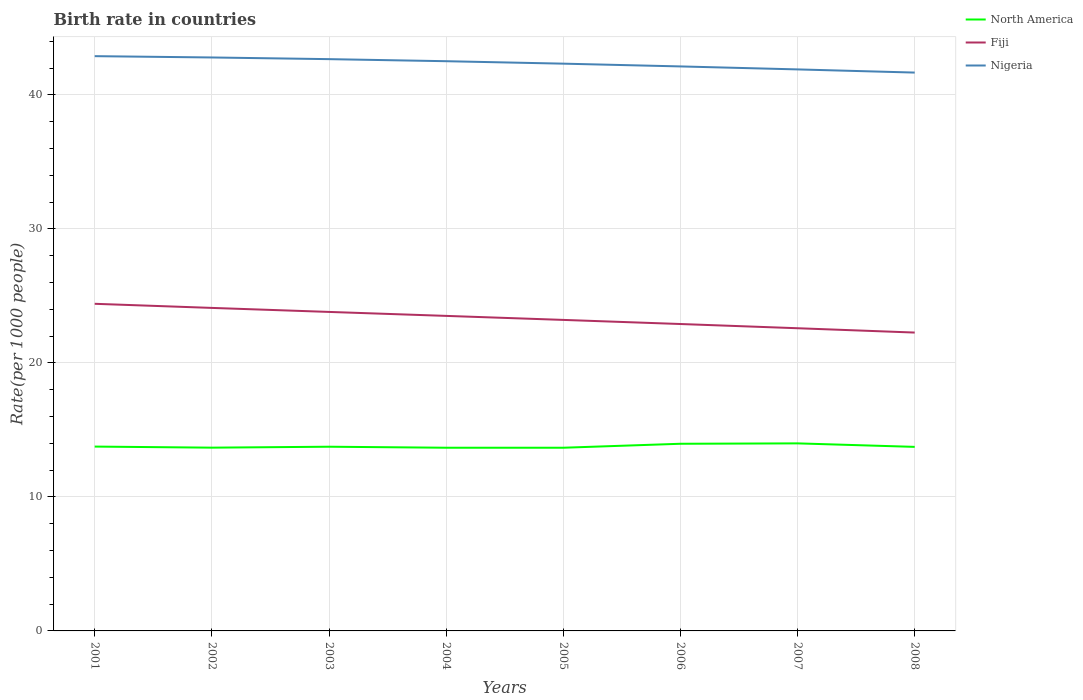Does the line corresponding to North America intersect with the line corresponding to Nigeria?
Give a very brief answer. No. Is the number of lines equal to the number of legend labels?
Offer a very short reply. Yes. Across all years, what is the maximum birth rate in Fiji?
Your response must be concise. 22.26. What is the total birth rate in Nigeria in the graph?
Ensure brevity in your answer.  0.99. What is the difference between the highest and the second highest birth rate in Nigeria?
Keep it short and to the point. 1.23. What is the difference between the highest and the lowest birth rate in North America?
Provide a succinct answer. 2. Is the birth rate in Nigeria strictly greater than the birth rate in North America over the years?
Offer a very short reply. No. How many lines are there?
Your answer should be very brief. 3. What is the difference between two consecutive major ticks on the Y-axis?
Provide a short and direct response. 10. Are the values on the major ticks of Y-axis written in scientific E-notation?
Your response must be concise. No. Where does the legend appear in the graph?
Provide a short and direct response. Top right. What is the title of the graph?
Make the answer very short. Birth rate in countries. Does "Cuba" appear as one of the legend labels in the graph?
Your answer should be compact. No. What is the label or title of the X-axis?
Provide a succinct answer. Years. What is the label or title of the Y-axis?
Offer a terse response. Rate(per 1000 people). What is the Rate(per 1000 people) of North America in 2001?
Ensure brevity in your answer.  13.76. What is the Rate(per 1000 people) in Fiji in 2001?
Give a very brief answer. 24.41. What is the Rate(per 1000 people) of Nigeria in 2001?
Provide a short and direct response. 42.89. What is the Rate(per 1000 people) in North America in 2002?
Offer a very short reply. 13.68. What is the Rate(per 1000 people) of Fiji in 2002?
Provide a short and direct response. 24.1. What is the Rate(per 1000 people) of Nigeria in 2002?
Your response must be concise. 42.79. What is the Rate(per 1000 people) in North America in 2003?
Provide a succinct answer. 13.75. What is the Rate(per 1000 people) in Fiji in 2003?
Provide a short and direct response. 23.8. What is the Rate(per 1000 people) of Nigeria in 2003?
Ensure brevity in your answer.  42.67. What is the Rate(per 1000 people) in North America in 2004?
Your response must be concise. 13.67. What is the Rate(per 1000 people) in Fiji in 2004?
Your answer should be compact. 23.51. What is the Rate(per 1000 people) of Nigeria in 2004?
Provide a short and direct response. 42.51. What is the Rate(per 1000 people) of North America in 2005?
Ensure brevity in your answer.  13.67. What is the Rate(per 1000 people) of Fiji in 2005?
Keep it short and to the point. 23.21. What is the Rate(per 1000 people) of Nigeria in 2005?
Make the answer very short. 42.33. What is the Rate(per 1000 people) of North America in 2006?
Your response must be concise. 13.97. What is the Rate(per 1000 people) of Fiji in 2006?
Give a very brief answer. 22.9. What is the Rate(per 1000 people) in Nigeria in 2006?
Your response must be concise. 42.12. What is the Rate(per 1000 people) of North America in 2007?
Provide a short and direct response. 13.99. What is the Rate(per 1000 people) of Fiji in 2007?
Ensure brevity in your answer.  22.59. What is the Rate(per 1000 people) of Nigeria in 2007?
Make the answer very short. 41.9. What is the Rate(per 1000 people) of North America in 2008?
Offer a terse response. 13.73. What is the Rate(per 1000 people) of Fiji in 2008?
Provide a succinct answer. 22.26. What is the Rate(per 1000 people) of Nigeria in 2008?
Offer a very short reply. 41.66. Across all years, what is the maximum Rate(per 1000 people) of North America?
Give a very brief answer. 13.99. Across all years, what is the maximum Rate(per 1000 people) of Fiji?
Offer a very short reply. 24.41. Across all years, what is the maximum Rate(per 1000 people) in Nigeria?
Your response must be concise. 42.89. Across all years, what is the minimum Rate(per 1000 people) in North America?
Offer a terse response. 13.67. Across all years, what is the minimum Rate(per 1000 people) in Fiji?
Your answer should be compact. 22.26. Across all years, what is the minimum Rate(per 1000 people) of Nigeria?
Provide a succinct answer. 41.66. What is the total Rate(per 1000 people) of North America in the graph?
Your answer should be compact. 110.21. What is the total Rate(per 1000 people) in Fiji in the graph?
Give a very brief answer. 186.78. What is the total Rate(per 1000 people) of Nigeria in the graph?
Ensure brevity in your answer.  338.87. What is the difference between the Rate(per 1000 people) of North America in 2001 and that in 2002?
Your answer should be very brief. 0.08. What is the difference between the Rate(per 1000 people) in Fiji in 2001 and that in 2002?
Offer a very short reply. 0.31. What is the difference between the Rate(per 1000 people) of Nigeria in 2001 and that in 2002?
Make the answer very short. 0.1. What is the difference between the Rate(per 1000 people) of North America in 2001 and that in 2003?
Provide a succinct answer. 0.01. What is the difference between the Rate(per 1000 people) in Fiji in 2001 and that in 2003?
Give a very brief answer. 0.61. What is the difference between the Rate(per 1000 people) of Nigeria in 2001 and that in 2003?
Ensure brevity in your answer.  0.22. What is the difference between the Rate(per 1000 people) of North America in 2001 and that in 2004?
Your answer should be very brief. 0.09. What is the difference between the Rate(per 1000 people) in Fiji in 2001 and that in 2004?
Your answer should be very brief. 0.9. What is the difference between the Rate(per 1000 people) in Nigeria in 2001 and that in 2004?
Your answer should be compact. 0.38. What is the difference between the Rate(per 1000 people) in North America in 2001 and that in 2005?
Your response must be concise. 0.09. What is the difference between the Rate(per 1000 people) in Fiji in 2001 and that in 2005?
Provide a succinct answer. 1.2. What is the difference between the Rate(per 1000 people) of Nigeria in 2001 and that in 2005?
Offer a terse response. 0.56. What is the difference between the Rate(per 1000 people) of North America in 2001 and that in 2006?
Provide a succinct answer. -0.21. What is the difference between the Rate(per 1000 people) of Fiji in 2001 and that in 2006?
Give a very brief answer. 1.51. What is the difference between the Rate(per 1000 people) in Nigeria in 2001 and that in 2006?
Your answer should be very brief. 0.77. What is the difference between the Rate(per 1000 people) in North America in 2001 and that in 2007?
Your response must be concise. -0.24. What is the difference between the Rate(per 1000 people) in Fiji in 2001 and that in 2007?
Keep it short and to the point. 1.82. What is the difference between the Rate(per 1000 people) in Nigeria in 2001 and that in 2007?
Offer a terse response. 0.99. What is the difference between the Rate(per 1000 people) in North America in 2001 and that in 2008?
Your answer should be very brief. 0.02. What is the difference between the Rate(per 1000 people) of Fiji in 2001 and that in 2008?
Make the answer very short. 2.15. What is the difference between the Rate(per 1000 people) in Nigeria in 2001 and that in 2008?
Offer a terse response. 1.23. What is the difference between the Rate(per 1000 people) of North America in 2002 and that in 2003?
Give a very brief answer. -0.07. What is the difference between the Rate(per 1000 people) of Fiji in 2002 and that in 2003?
Your answer should be very brief. 0.3. What is the difference between the Rate(per 1000 people) of Nigeria in 2002 and that in 2003?
Your answer should be very brief. 0.12. What is the difference between the Rate(per 1000 people) of North America in 2002 and that in 2004?
Give a very brief answer. 0.01. What is the difference between the Rate(per 1000 people) of Fiji in 2002 and that in 2004?
Your answer should be compact. 0.59. What is the difference between the Rate(per 1000 people) in Nigeria in 2002 and that in 2004?
Make the answer very short. 0.28. What is the difference between the Rate(per 1000 people) in North America in 2002 and that in 2005?
Keep it short and to the point. 0.01. What is the difference between the Rate(per 1000 people) of Fiji in 2002 and that in 2005?
Your answer should be compact. 0.9. What is the difference between the Rate(per 1000 people) in Nigeria in 2002 and that in 2005?
Offer a very short reply. 0.46. What is the difference between the Rate(per 1000 people) in North America in 2002 and that in 2006?
Make the answer very short. -0.29. What is the difference between the Rate(per 1000 people) in Fiji in 2002 and that in 2006?
Keep it short and to the point. 1.2. What is the difference between the Rate(per 1000 people) in Nigeria in 2002 and that in 2006?
Your answer should be very brief. 0.67. What is the difference between the Rate(per 1000 people) in North America in 2002 and that in 2007?
Ensure brevity in your answer.  -0.32. What is the difference between the Rate(per 1000 people) in Fiji in 2002 and that in 2007?
Make the answer very short. 1.52. What is the difference between the Rate(per 1000 people) in Nigeria in 2002 and that in 2007?
Keep it short and to the point. 0.89. What is the difference between the Rate(per 1000 people) in North America in 2002 and that in 2008?
Ensure brevity in your answer.  -0.06. What is the difference between the Rate(per 1000 people) in Fiji in 2002 and that in 2008?
Provide a succinct answer. 1.84. What is the difference between the Rate(per 1000 people) of Nigeria in 2002 and that in 2008?
Your answer should be compact. 1.13. What is the difference between the Rate(per 1000 people) of North America in 2003 and that in 2004?
Make the answer very short. 0.08. What is the difference between the Rate(per 1000 people) of Fiji in 2003 and that in 2004?
Provide a short and direct response. 0.3. What is the difference between the Rate(per 1000 people) of Nigeria in 2003 and that in 2004?
Your answer should be very brief. 0.15. What is the difference between the Rate(per 1000 people) of North America in 2003 and that in 2005?
Provide a succinct answer. 0.08. What is the difference between the Rate(per 1000 people) of Fiji in 2003 and that in 2005?
Your response must be concise. 0.6. What is the difference between the Rate(per 1000 people) in Nigeria in 2003 and that in 2005?
Your answer should be compact. 0.34. What is the difference between the Rate(per 1000 people) of North America in 2003 and that in 2006?
Ensure brevity in your answer.  -0.22. What is the difference between the Rate(per 1000 people) in Fiji in 2003 and that in 2006?
Make the answer very short. 0.9. What is the difference between the Rate(per 1000 people) in Nigeria in 2003 and that in 2006?
Provide a short and direct response. 0.54. What is the difference between the Rate(per 1000 people) in North America in 2003 and that in 2007?
Ensure brevity in your answer.  -0.25. What is the difference between the Rate(per 1000 people) of Fiji in 2003 and that in 2007?
Offer a very short reply. 1.22. What is the difference between the Rate(per 1000 people) in Nigeria in 2003 and that in 2007?
Make the answer very short. 0.77. What is the difference between the Rate(per 1000 people) in North America in 2003 and that in 2008?
Keep it short and to the point. 0.01. What is the difference between the Rate(per 1000 people) of Fiji in 2003 and that in 2008?
Make the answer very short. 1.54. What is the difference between the Rate(per 1000 people) of Nigeria in 2003 and that in 2008?
Ensure brevity in your answer.  1. What is the difference between the Rate(per 1000 people) in Nigeria in 2004 and that in 2005?
Your answer should be very brief. 0.18. What is the difference between the Rate(per 1000 people) in North America in 2004 and that in 2006?
Make the answer very short. -0.3. What is the difference between the Rate(per 1000 people) in Fiji in 2004 and that in 2006?
Provide a succinct answer. 0.61. What is the difference between the Rate(per 1000 people) in Nigeria in 2004 and that in 2006?
Give a very brief answer. 0.39. What is the difference between the Rate(per 1000 people) in North America in 2004 and that in 2007?
Ensure brevity in your answer.  -0.32. What is the difference between the Rate(per 1000 people) of Fiji in 2004 and that in 2007?
Your answer should be very brief. 0.92. What is the difference between the Rate(per 1000 people) in Nigeria in 2004 and that in 2007?
Ensure brevity in your answer.  0.61. What is the difference between the Rate(per 1000 people) in North America in 2004 and that in 2008?
Your answer should be compact. -0.06. What is the difference between the Rate(per 1000 people) in Fiji in 2004 and that in 2008?
Make the answer very short. 1.25. What is the difference between the Rate(per 1000 people) of Nigeria in 2004 and that in 2008?
Offer a terse response. 0.85. What is the difference between the Rate(per 1000 people) of North America in 2005 and that in 2006?
Give a very brief answer. -0.3. What is the difference between the Rate(per 1000 people) in Fiji in 2005 and that in 2006?
Provide a short and direct response. 0.31. What is the difference between the Rate(per 1000 people) of Nigeria in 2005 and that in 2006?
Your answer should be very brief. 0.21. What is the difference between the Rate(per 1000 people) of North America in 2005 and that in 2007?
Ensure brevity in your answer.  -0.33. What is the difference between the Rate(per 1000 people) in Fiji in 2005 and that in 2007?
Your answer should be compact. 0.62. What is the difference between the Rate(per 1000 people) of Nigeria in 2005 and that in 2007?
Your answer should be very brief. 0.43. What is the difference between the Rate(per 1000 people) in North America in 2005 and that in 2008?
Keep it short and to the point. -0.06. What is the difference between the Rate(per 1000 people) of Fiji in 2005 and that in 2008?
Your response must be concise. 0.94. What is the difference between the Rate(per 1000 people) in Nigeria in 2005 and that in 2008?
Your response must be concise. 0.67. What is the difference between the Rate(per 1000 people) of North America in 2006 and that in 2007?
Offer a very short reply. -0.03. What is the difference between the Rate(per 1000 people) in Fiji in 2006 and that in 2007?
Offer a terse response. 0.32. What is the difference between the Rate(per 1000 people) in Nigeria in 2006 and that in 2007?
Make the answer very short. 0.22. What is the difference between the Rate(per 1000 people) of North America in 2006 and that in 2008?
Give a very brief answer. 0.23. What is the difference between the Rate(per 1000 people) in Fiji in 2006 and that in 2008?
Provide a succinct answer. 0.64. What is the difference between the Rate(per 1000 people) of Nigeria in 2006 and that in 2008?
Keep it short and to the point. 0.46. What is the difference between the Rate(per 1000 people) in North America in 2007 and that in 2008?
Provide a succinct answer. 0.26. What is the difference between the Rate(per 1000 people) of Fiji in 2007 and that in 2008?
Make the answer very short. 0.32. What is the difference between the Rate(per 1000 people) of Nigeria in 2007 and that in 2008?
Offer a terse response. 0.24. What is the difference between the Rate(per 1000 people) of North America in 2001 and the Rate(per 1000 people) of Fiji in 2002?
Ensure brevity in your answer.  -10.35. What is the difference between the Rate(per 1000 people) in North America in 2001 and the Rate(per 1000 people) in Nigeria in 2002?
Your answer should be very brief. -29.04. What is the difference between the Rate(per 1000 people) of Fiji in 2001 and the Rate(per 1000 people) of Nigeria in 2002?
Provide a short and direct response. -18.38. What is the difference between the Rate(per 1000 people) in North America in 2001 and the Rate(per 1000 people) in Fiji in 2003?
Provide a succinct answer. -10.05. What is the difference between the Rate(per 1000 people) of North America in 2001 and the Rate(per 1000 people) of Nigeria in 2003?
Your answer should be very brief. -28.91. What is the difference between the Rate(per 1000 people) of Fiji in 2001 and the Rate(per 1000 people) of Nigeria in 2003?
Make the answer very short. -18.26. What is the difference between the Rate(per 1000 people) of North America in 2001 and the Rate(per 1000 people) of Fiji in 2004?
Your answer should be very brief. -9.75. What is the difference between the Rate(per 1000 people) of North America in 2001 and the Rate(per 1000 people) of Nigeria in 2004?
Your answer should be very brief. -28.76. What is the difference between the Rate(per 1000 people) in Fiji in 2001 and the Rate(per 1000 people) in Nigeria in 2004?
Provide a succinct answer. -18.1. What is the difference between the Rate(per 1000 people) in North America in 2001 and the Rate(per 1000 people) in Fiji in 2005?
Your response must be concise. -9.45. What is the difference between the Rate(per 1000 people) in North America in 2001 and the Rate(per 1000 people) in Nigeria in 2005?
Keep it short and to the point. -28.57. What is the difference between the Rate(per 1000 people) of Fiji in 2001 and the Rate(per 1000 people) of Nigeria in 2005?
Your answer should be very brief. -17.92. What is the difference between the Rate(per 1000 people) of North America in 2001 and the Rate(per 1000 people) of Fiji in 2006?
Make the answer very short. -9.15. What is the difference between the Rate(per 1000 people) of North America in 2001 and the Rate(per 1000 people) of Nigeria in 2006?
Your response must be concise. -28.37. What is the difference between the Rate(per 1000 people) of Fiji in 2001 and the Rate(per 1000 people) of Nigeria in 2006?
Your answer should be very brief. -17.71. What is the difference between the Rate(per 1000 people) in North America in 2001 and the Rate(per 1000 people) in Fiji in 2007?
Provide a short and direct response. -8.83. What is the difference between the Rate(per 1000 people) of North America in 2001 and the Rate(per 1000 people) of Nigeria in 2007?
Your answer should be compact. -28.14. What is the difference between the Rate(per 1000 people) in Fiji in 2001 and the Rate(per 1000 people) in Nigeria in 2007?
Provide a succinct answer. -17.49. What is the difference between the Rate(per 1000 people) in North America in 2001 and the Rate(per 1000 people) in Fiji in 2008?
Give a very brief answer. -8.51. What is the difference between the Rate(per 1000 people) in North America in 2001 and the Rate(per 1000 people) in Nigeria in 2008?
Make the answer very short. -27.91. What is the difference between the Rate(per 1000 people) in Fiji in 2001 and the Rate(per 1000 people) in Nigeria in 2008?
Give a very brief answer. -17.25. What is the difference between the Rate(per 1000 people) in North America in 2002 and the Rate(per 1000 people) in Fiji in 2003?
Offer a terse response. -10.13. What is the difference between the Rate(per 1000 people) in North America in 2002 and the Rate(per 1000 people) in Nigeria in 2003?
Offer a very short reply. -28.99. What is the difference between the Rate(per 1000 people) of Fiji in 2002 and the Rate(per 1000 people) of Nigeria in 2003?
Make the answer very short. -18.56. What is the difference between the Rate(per 1000 people) in North America in 2002 and the Rate(per 1000 people) in Fiji in 2004?
Offer a terse response. -9.83. What is the difference between the Rate(per 1000 people) in North America in 2002 and the Rate(per 1000 people) in Nigeria in 2004?
Ensure brevity in your answer.  -28.84. What is the difference between the Rate(per 1000 people) of Fiji in 2002 and the Rate(per 1000 people) of Nigeria in 2004?
Keep it short and to the point. -18.41. What is the difference between the Rate(per 1000 people) in North America in 2002 and the Rate(per 1000 people) in Fiji in 2005?
Make the answer very short. -9.53. What is the difference between the Rate(per 1000 people) of North America in 2002 and the Rate(per 1000 people) of Nigeria in 2005?
Provide a succinct answer. -28.65. What is the difference between the Rate(per 1000 people) in Fiji in 2002 and the Rate(per 1000 people) in Nigeria in 2005?
Offer a terse response. -18.23. What is the difference between the Rate(per 1000 people) in North America in 2002 and the Rate(per 1000 people) in Fiji in 2006?
Offer a terse response. -9.23. What is the difference between the Rate(per 1000 people) in North America in 2002 and the Rate(per 1000 people) in Nigeria in 2006?
Provide a short and direct response. -28.45. What is the difference between the Rate(per 1000 people) of Fiji in 2002 and the Rate(per 1000 people) of Nigeria in 2006?
Give a very brief answer. -18.02. What is the difference between the Rate(per 1000 people) in North America in 2002 and the Rate(per 1000 people) in Fiji in 2007?
Ensure brevity in your answer.  -8.91. What is the difference between the Rate(per 1000 people) of North America in 2002 and the Rate(per 1000 people) of Nigeria in 2007?
Your answer should be very brief. -28.22. What is the difference between the Rate(per 1000 people) of Fiji in 2002 and the Rate(per 1000 people) of Nigeria in 2007?
Keep it short and to the point. -17.8. What is the difference between the Rate(per 1000 people) in North America in 2002 and the Rate(per 1000 people) in Fiji in 2008?
Keep it short and to the point. -8.59. What is the difference between the Rate(per 1000 people) in North America in 2002 and the Rate(per 1000 people) in Nigeria in 2008?
Your response must be concise. -27.99. What is the difference between the Rate(per 1000 people) in Fiji in 2002 and the Rate(per 1000 people) in Nigeria in 2008?
Give a very brief answer. -17.56. What is the difference between the Rate(per 1000 people) of North America in 2003 and the Rate(per 1000 people) of Fiji in 2004?
Offer a terse response. -9.76. What is the difference between the Rate(per 1000 people) of North America in 2003 and the Rate(per 1000 people) of Nigeria in 2004?
Your answer should be very brief. -28.77. What is the difference between the Rate(per 1000 people) of Fiji in 2003 and the Rate(per 1000 people) of Nigeria in 2004?
Offer a very short reply. -18.71. What is the difference between the Rate(per 1000 people) of North America in 2003 and the Rate(per 1000 people) of Fiji in 2005?
Your response must be concise. -9.46. What is the difference between the Rate(per 1000 people) in North America in 2003 and the Rate(per 1000 people) in Nigeria in 2005?
Provide a short and direct response. -28.58. What is the difference between the Rate(per 1000 people) in Fiji in 2003 and the Rate(per 1000 people) in Nigeria in 2005?
Your answer should be compact. -18.52. What is the difference between the Rate(per 1000 people) in North America in 2003 and the Rate(per 1000 people) in Fiji in 2006?
Give a very brief answer. -9.16. What is the difference between the Rate(per 1000 people) in North America in 2003 and the Rate(per 1000 people) in Nigeria in 2006?
Your response must be concise. -28.38. What is the difference between the Rate(per 1000 people) in Fiji in 2003 and the Rate(per 1000 people) in Nigeria in 2006?
Provide a succinct answer. -18.32. What is the difference between the Rate(per 1000 people) of North America in 2003 and the Rate(per 1000 people) of Fiji in 2007?
Keep it short and to the point. -8.84. What is the difference between the Rate(per 1000 people) of North America in 2003 and the Rate(per 1000 people) of Nigeria in 2007?
Your answer should be compact. -28.15. What is the difference between the Rate(per 1000 people) in Fiji in 2003 and the Rate(per 1000 people) in Nigeria in 2007?
Keep it short and to the point. -18.1. What is the difference between the Rate(per 1000 people) in North America in 2003 and the Rate(per 1000 people) in Fiji in 2008?
Provide a short and direct response. -8.52. What is the difference between the Rate(per 1000 people) in North America in 2003 and the Rate(per 1000 people) in Nigeria in 2008?
Your answer should be compact. -27.92. What is the difference between the Rate(per 1000 people) in Fiji in 2003 and the Rate(per 1000 people) in Nigeria in 2008?
Ensure brevity in your answer.  -17.86. What is the difference between the Rate(per 1000 people) of North America in 2004 and the Rate(per 1000 people) of Fiji in 2005?
Your answer should be very brief. -9.54. What is the difference between the Rate(per 1000 people) of North America in 2004 and the Rate(per 1000 people) of Nigeria in 2005?
Provide a short and direct response. -28.66. What is the difference between the Rate(per 1000 people) in Fiji in 2004 and the Rate(per 1000 people) in Nigeria in 2005?
Offer a very short reply. -18.82. What is the difference between the Rate(per 1000 people) of North America in 2004 and the Rate(per 1000 people) of Fiji in 2006?
Keep it short and to the point. -9.23. What is the difference between the Rate(per 1000 people) of North America in 2004 and the Rate(per 1000 people) of Nigeria in 2006?
Make the answer very short. -28.45. What is the difference between the Rate(per 1000 people) in Fiji in 2004 and the Rate(per 1000 people) in Nigeria in 2006?
Provide a succinct answer. -18.61. What is the difference between the Rate(per 1000 people) of North America in 2004 and the Rate(per 1000 people) of Fiji in 2007?
Offer a very short reply. -8.92. What is the difference between the Rate(per 1000 people) in North America in 2004 and the Rate(per 1000 people) in Nigeria in 2007?
Your answer should be compact. -28.23. What is the difference between the Rate(per 1000 people) of Fiji in 2004 and the Rate(per 1000 people) of Nigeria in 2007?
Make the answer very short. -18.39. What is the difference between the Rate(per 1000 people) of North America in 2004 and the Rate(per 1000 people) of Fiji in 2008?
Provide a succinct answer. -8.59. What is the difference between the Rate(per 1000 people) in North America in 2004 and the Rate(per 1000 people) in Nigeria in 2008?
Provide a succinct answer. -27.99. What is the difference between the Rate(per 1000 people) in Fiji in 2004 and the Rate(per 1000 people) in Nigeria in 2008?
Provide a succinct answer. -18.16. What is the difference between the Rate(per 1000 people) of North America in 2005 and the Rate(per 1000 people) of Fiji in 2006?
Your answer should be compact. -9.23. What is the difference between the Rate(per 1000 people) in North America in 2005 and the Rate(per 1000 people) in Nigeria in 2006?
Provide a short and direct response. -28.45. What is the difference between the Rate(per 1000 people) of Fiji in 2005 and the Rate(per 1000 people) of Nigeria in 2006?
Your response must be concise. -18.91. What is the difference between the Rate(per 1000 people) of North America in 2005 and the Rate(per 1000 people) of Fiji in 2007?
Ensure brevity in your answer.  -8.92. What is the difference between the Rate(per 1000 people) of North America in 2005 and the Rate(per 1000 people) of Nigeria in 2007?
Make the answer very short. -28.23. What is the difference between the Rate(per 1000 people) in Fiji in 2005 and the Rate(per 1000 people) in Nigeria in 2007?
Give a very brief answer. -18.69. What is the difference between the Rate(per 1000 people) of North America in 2005 and the Rate(per 1000 people) of Fiji in 2008?
Your answer should be very brief. -8.59. What is the difference between the Rate(per 1000 people) in North America in 2005 and the Rate(per 1000 people) in Nigeria in 2008?
Keep it short and to the point. -27.99. What is the difference between the Rate(per 1000 people) of Fiji in 2005 and the Rate(per 1000 people) of Nigeria in 2008?
Keep it short and to the point. -18.45. What is the difference between the Rate(per 1000 people) in North America in 2006 and the Rate(per 1000 people) in Fiji in 2007?
Provide a short and direct response. -8.62. What is the difference between the Rate(per 1000 people) in North America in 2006 and the Rate(per 1000 people) in Nigeria in 2007?
Your response must be concise. -27.93. What is the difference between the Rate(per 1000 people) in Fiji in 2006 and the Rate(per 1000 people) in Nigeria in 2007?
Keep it short and to the point. -19. What is the difference between the Rate(per 1000 people) in North America in 2006 and the Rate(per 1000 people) in Fiji in 2008?
Ensure brevity in your answer.  -8.3. What is the difference between the Rate(per 1000 people) in North America in 2006 and the Rate(per 1000 people) in Nigeria in 2008?
Ensure brevity in your answer.  -27.7. What is the difference between the Rate(per 1000 people) in Fiji in 2006 and the Rate(per 1000 people) in Nigeria in 2008?
Your answer should be compact. -18.76. What is the difference between the Rate(per 1000 people) of North America in 2007 and the Rate(per 1000 people) of Fiji in 2008?
Give a very brief answer. -8.27. What is the difference between the Rate(per 1000 people) of North America in 2007 and the Rate(per 1000 people) of Nigeria in 2008?
Your response must be concise. -27.67. What is the difference between the Rate(per 1000 people) of Fiji in 2007 and the Rate(per 1000 people) of Nigeria in 2008?
Your response must be concise. -19.08. What is the average Rate(per 1000 people) of North America per year?
Provide a short and direct response. 13.78. What is the average Rate(per 1000 people) of Fiji per year?
Your response must be concise. 23.35. What is the average Rate(per 1000 people) in Nigeria per year?
Your answer should be compact. 42.36. In the year 2001, what is the difference between the Rate(per 1000 people) in North America and Rate(per 1000 people) in Fiji?
Your answer should be compact. -10.65. In the year 2001, what is the difference between the Rate(per 1000 people) in North America and Rate(per 1000 people) in Nigeria?
Provide a short and direct response. -29.13. In the year 2001, what is the difference between the Rate(per 1000 people) of Fiji and Rate(per 1000 people) of Nigeria?
Your response must be concise. -18.48. In the year 2002, what is the difference between the Rate(per 1000 people) in North America and Rate(per 1000 people) in Fiji?
Your answer should be compact. -10.43. In the year 2002, what is the difference between the Rate(per 1000 people) in North America and Rate(per 1000 people) in Nigeria?
Offer a very short reply. -29.12. In the year 2002, what is the difference between the Rate(per 1000 people) in Fiji and Rate(per 1000 people) in Nigeria?
Provide a short and direct response. -18.69. In the year 2003, what is the difference between the Rate(per 1000 people) of North America and Rate(per 1000 people) of Fiji?
Give a very brief answer. -10.06. In the year 2003, what is the difference between the Rate(per 1000 people) in North America and Rate(per 1000 people) in Nigeria?
Offer a very short reply. -28.92. In the year 2003, what is the difference between the Rate(per 1000 people) in Fiji and Rate(per 1000 people) in Nigeria?
Your answer should be compact. -18.86. In the year 2004, what is the difference between the Rate(per 1000 people) in North America and Rate(per 1000 people) in Fiji?
Give a very brief answer. -9.84. In the year 2004, what is the difference between the Rate(per 1000 people) in North America and Rate(per 1000 people) in Nigeria?
Offer a terse response. -28.84. In the year 2004, what is the difference between the Rate(per 1000 people) of Fiji and Rate(per 1000 people) of Nigeria?
Give a very brief answer. -19. In the year 2005, what is the difference between the Rate(per 1000 people) of North America and Rate(per 1000 people) of Fiji?
Your answer should be very brief. -9.54. In the year 2005, what is the difference between the Rate(per 1000 people) of North America and Rate(per 1000 people) of Nigeria?
Offer a very short reply. -28.66. In the year 2005, what is the difference between the Rate(per 1000 people) in Fiji and Rate(per 1000 people) in Nigeria?
Your answer should be compact. -19.12. In the year 2006, what is the difference between the Rate(per 1000 people) in North America and Rate(per 1000 people) in Fiji?
Give a very brief answer. -8.94. In the year 2006, what is the difference between the Rate(per 1000 people) of North America and Rate(per 1000 people) of Nigeria?
Your answer should be compact. -28.16. In the year 2006, what is the difference between the Rate(per 1000 people) in Fiji and Rate(per 1000 people) in Nigeria?
Provide a succinct answer. -19.22. In the year 2007, what is the difference between the Rate(per 1000 people) of North America and Rate(per 1000 people) of Fiji?
Provide a succinct answer. -8.59. In the year 2007, what is the difference between the Rate(per 1000 people) in North America and Rate(per 1000 people) in Nigeria?
Make the answer very short. -27.91. In the year 2007, what is the difference between the Rate(per 1000 people) in Fiji and Rate(per 1000 people) in Nigeria?
Offer a terse response. -19.31. In the year 2008, what is the difference between the Rate(per 1000 people) in North America and Rate(per 1000 people) in Fiji?
Offer a terse response. -8.53. In the year 2008, what is the difference between the Rate(per 1000 people) of North America and Rate(per 1000 people) of Nigeria?
Ensure brevity in your answer.  -27.93. In the year 2008, what is the difference between the Rate(per 1000 people) in Fiji and Rate(per 1000 people) in Nigeria?
Give a very brief answer. -19.4. What is the ratio of the Rate(per 1000 people) in North America in 2001 to that in 2002?
Provide a succinct answer. 1.01. What is the ratio of the Rate(per 1000 people) of Fiji in 2001 to that in 2002?
Give a very brief answer. 1.01. What is the ratio of the Rate(per 1000 people) in North America in 2001 to that in 2003?
Offer a terse response. 1. What is the ratio of the Rate(per 1000 people) of Fiji in 2001 to that in 2003?
Provide a succinct answer. 1.03. What is the ratio of the Rate(per 1000 people) of Nigeria in 2001 to that in 2003?
Your answer should be compact. 1.01. What is the ratio of the Rate(per 1000 people) in North America in 2001 to that in 2004?
Your answer should be very brief. 1.01. What is the ratio of the Rate(per 1000 people) of Fiji in 2001 to that in 2004?
Your response must be concise. 1.04. What is the ratio of the Rate(per 1000 people) in Nigeria in 2001 to that in 2004?
Your answer should be very brief. 1.01. What is the ratio of the Rate(per 1000 people) in Fiji in 2001 to that in 2005?
Keep it short and to the point. 1.05. What is the ratio of the Rate(per 1000 people) in Nigeria in 2001 to that in 2005?
Your response must be concise. 1.01. What is the ratio of the Rate(per 1000 people) in Fiji in 2001 to that in 2006?
Keep it short and to the point. 1.07. What is the ratio of the Rate(per 1000 people) in Nigeria in 2001 to that in 2006?
Your answer should be compact. 1.02. What is the ratio of the Rate(per 1000 people) of North America in 2001 to that in 2007?
Offer a terse response. 0.98. What is the ratio of the Rate(per 1000 people) in Fiji in 2001 to that in 2007?
Your answer should be compact. 1.08. What is the ratio of the Rate(per 1000 people) of Nigeria in 2001 to that in 2007?
Your answer should be compact. 1.02. What is the ratio of the Rate(per 1000 people) of Fiji in 2001 to that in 2008?
Keep it short and to the point. 1.1. What is the ratio of the Rate(per 1000 people) in Nigeria in 2001 to that in 2008?
Ensure brevity in your answer.  1.03. What is the ratio of the Rate(per 1000 people) of Fiji in 2002 to that in 2003?
Give a very brief answer. 1.01. What is the ratio of the Rate(per 1000 people) in North America in 2002 to that in 2004?
Offer a terse response. 1. What is the ratio of the Rate(per 1000 people) in Fiji in 2002 to that in 2004?
Provide a short and direct response. 1.03. What is the ratio of the Rate(per 1000 people) of Nigeria in 2002 to that in 2004?
Offer a terse response. 1.01. What is the ratio of the Rate(per 1000 people) of Fiji in 2002 to that in 2005?
Offer a very short reply. 1.04. What is the ratio of the Rate(per 1000 people) in Nigeria in 2002 to that in 2005?
Give a very brief answer. 1.01. What is the ratio of the Rate(per 1000 people) in North America in 2002 to that in 2006?
Offer a terse response. 0.98. What is the ratio of the Rate(per 1000 people) of Fiji in 2002 to that in 2006?
Make the answer very short. 1.05. What is the ratio of the Rate(per 1000 people) in Nigeria in 2002 to that in 2006?
Provide a short and direct response. 1.02. What is the ratio of the Rate(per 1000 people) in North America in 2002 to that in 2007?
Your answer should be very brief. 0.98. What is the ratio of the Rate(per 1000 people) of Fiji in 2002 to that in 2007?
Provide a succinct answer. 1.07. What is the ratio of the Rate(per 1000 people) in Nigeria in 2002 to that in 2007?
Your answer should be compact. 1.02. What is the ratio of the Rate(per 1000 people) in Fiji in 2002 to that in 2008?
Offer a terse response. 1.08. What is the ratio of the Rate(per 1000 people) of Nigeria in 2002 to that in 2008?
Your answer should be very brief. 1.03. What is the ratio of the Rate(per 1000 people) in Fiji in 2003 to that in 2004?
Provide a short and direct response. 1.01. What is the ratio of the Rate(per 1000 people) of Nigeria in 2003 to that in 2004?
Your answer should be compact. 1. What is the ratio of the Rate(per 1000 people) of Fiji in 2003 to that in 2005?
Provide a succinct answer. 1.03. What is the ratio of the Rate(per 1000 people) in Nigeria in 2003 to that in 2005?
Provide a short and direct response. 1.01. What is the ratio of the Rate(per 1000 people) of North America in 2003 to that in 2006?
Offer a terse response. 0.98. What is the ratio of the Rate(per 1000 people) in Fiji in 2003 to that in 2006?
Provide a short and direct response. 1.04. What is the ratio of the Rate(per 1000 people) of Nigeria in 2003 to that in 2006?
Give a very brief answer. 1.01. What is the ratio of the Rate(per 1000 people) in North America in 2003 to that in 2007?
Provide a succinct answer. 0.98. What is the ratio of the Rate(per 1000 people) in Fiji in 2003 to that in 2007?
Give a very brief answer. 1.05. What is the ratio of the Rate(per 1000 people) of Nigeria in 2003 to that in 2007?
Offer a terse response. 1.02. What is the ratio of the Rate(per 1000 people) of Fiji in 2003 to that in 2008?
Provide a succinct answer. 1.07. What is the ratio of the Rate(per 1000 people) of Nigeria in 2003 to that in 2008?
Offer a very short reply. 1.02. What is the ratio of the Rate(per 1000 people) in North America in 2004 to that in 2005?
Your answer should be compact. 1. What is the ratio of the Rate(per 1000 people) in Fiji in 2004 to that in 2005?
Your answer should be very brief. 1.01. What is the ratio of the Rate(per 1000 people) of North America in 2004 to that in 2006?
Keep it short and to the point. 0.98. What is the ratio of the Rate(per 1000 people) of Fiji in 2004 to that in 2006?
Your answer should be compact. 1.03. What is the ratio of the Rate(per 1000 people) in Nigeria in 2004 to that in 2006?
Make the answer very short. 1.01. What is the ratio of the Rate(per 1000 people) in North America in 2004 to that in 2007?
Offer a terse response. 0.98. What is the ratio of the Rate(per 1000 people) of Fiji in 2004 to that in 2007?
Your answer should be compact. 1.04. What is the ratio of the Rate(per 1000 people) of Nigeria in 2004 to that in 2007?
Your response must be concise. 1.01. What is the ratio of the Rate(per 1000 people) in Fiji in 2004 to that in 2008?
Your response must be concise. 1.06. What is the ratio of the Rate(per 1000 people) of Nigeria in 2004 to that in 2008?
Provide a succinct answer. 1.02. What is the ratio of the Rate(per 1000 people) in North America in 2005 to that in 2006?
Give a very brief answer. 0.98. What is the ratio of the Rate(per 1000 people) in Fiji in 2005 to that in 2006?
Provide a succinct answer. 1.01. What is the ratio of the Rate(per 1000 people) in North America in 2005 to that in 2007?
Your response must be concise. 0.98. What is the ratio of the Rate(per 1000 people) of Fiji in 2005 to that in 2007?
Ensure brevity in your answer.  1.03. What is the ratio of the Rate(per 1000 people) in Nigeria in 2005 to that in 2007?
Your response must be concise. 1.01. What is the ratio of the Rate(per 1000 people) of Fiji in 2005 to that in 2008?
Provide a succinct answer. 1.04. What is the ratio of the Rate(per 1000 people) of Fiji in 2006 to that in 2007?
Your answer should be very brief. 1.01. What is the ratio of the Rate(per 1000 people) of Nigeria in 2006 to that in 2007?
Provide a short and direct response. 1.01. What is the ratio of the Rate(per 1000 people) of North America in 2006 to that in 2008?
Offer a very short reply. 1.02. What is the ratio of the Rate(per 1000 people) in Fiji in 2006 to that in 2008?
Your answer should be very brief. 1.03. What is the ratio of the Rate(per 1000 people) in Nigeria in 2006 to that in 2008?
Offer a terse response. 1.01. What is the ratio of the Rate(per 1000 people) of North America in 2007 to that in 2008?
Keep it short and to the point. 1.02. What is the ratio of the Rate(per 1000 people) of Fiji in 2007 to that in 2008?
Keep it short and to the point. 1.01. What is the ratio of the Rate(per 1000 people) of Nigeria in 2007 to that in 2008?
Keep it short and to the point. 1.01. What is the difference between the highest and the second highest Rate(per 1000 people) of North America?
Ensure brevity in your answer.  0.03. What is the difference between the highest and the second highest Rate(per 1000 people) in Fiji?
Your answer should be very brief. 0.31. What is the difference between the highest and the second highest Rate(per 1000 people) in Nigeria?
Provide a succinct answer. 0.1. What is the difference between the highest and the lowest Rate(per 1000 people) in North America?
Your answer should be compact. 0.33. What is the difference between the highest and the lowest Rate(per 1000 people) in Fiji?
Ensure brevity in your answer.  2.15. What is the difference between the highest and the lowest Rate(per 1000 people) in Nigeria?
Provide a short and direct response. 1.23. 